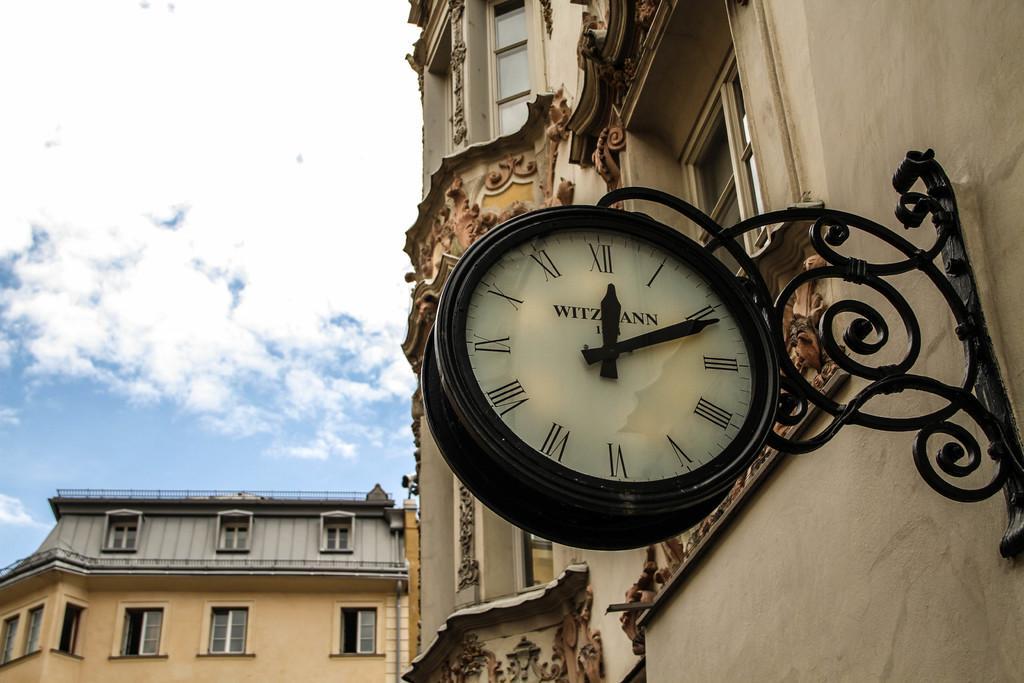Describe this image in one or two sentences. It is a wall clock and these are the buildings, at the top it's a sky. 